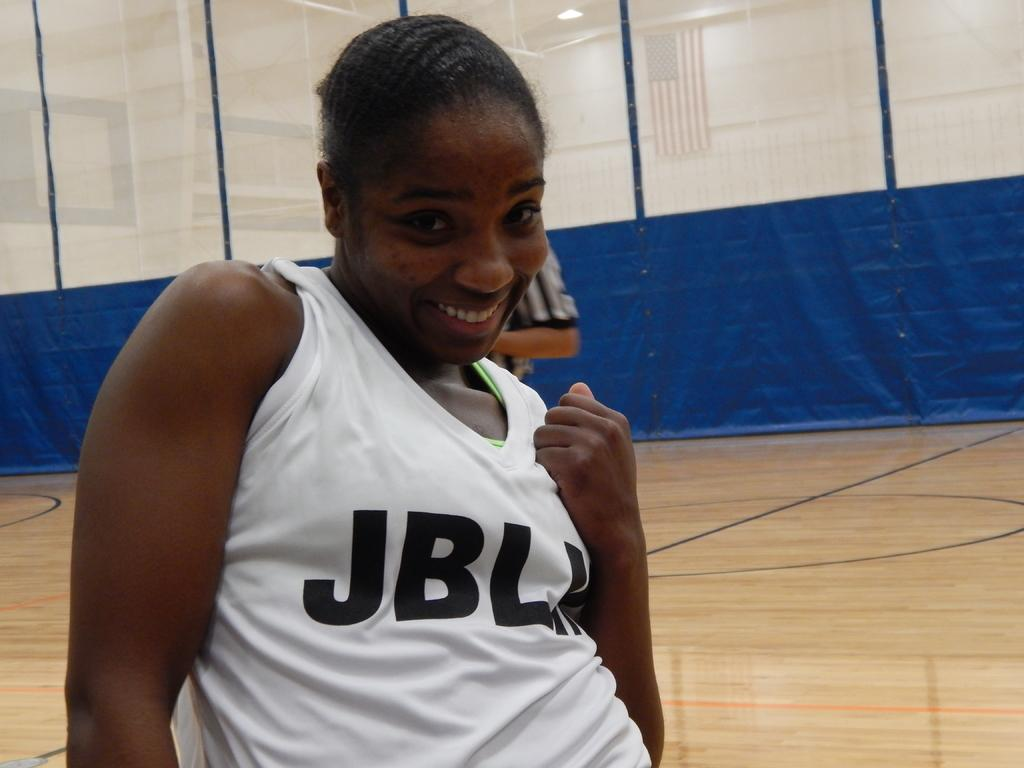<image>
Relay a brief, clear account of the picture shown. A woman in a white JBL jersey makes a pose. 